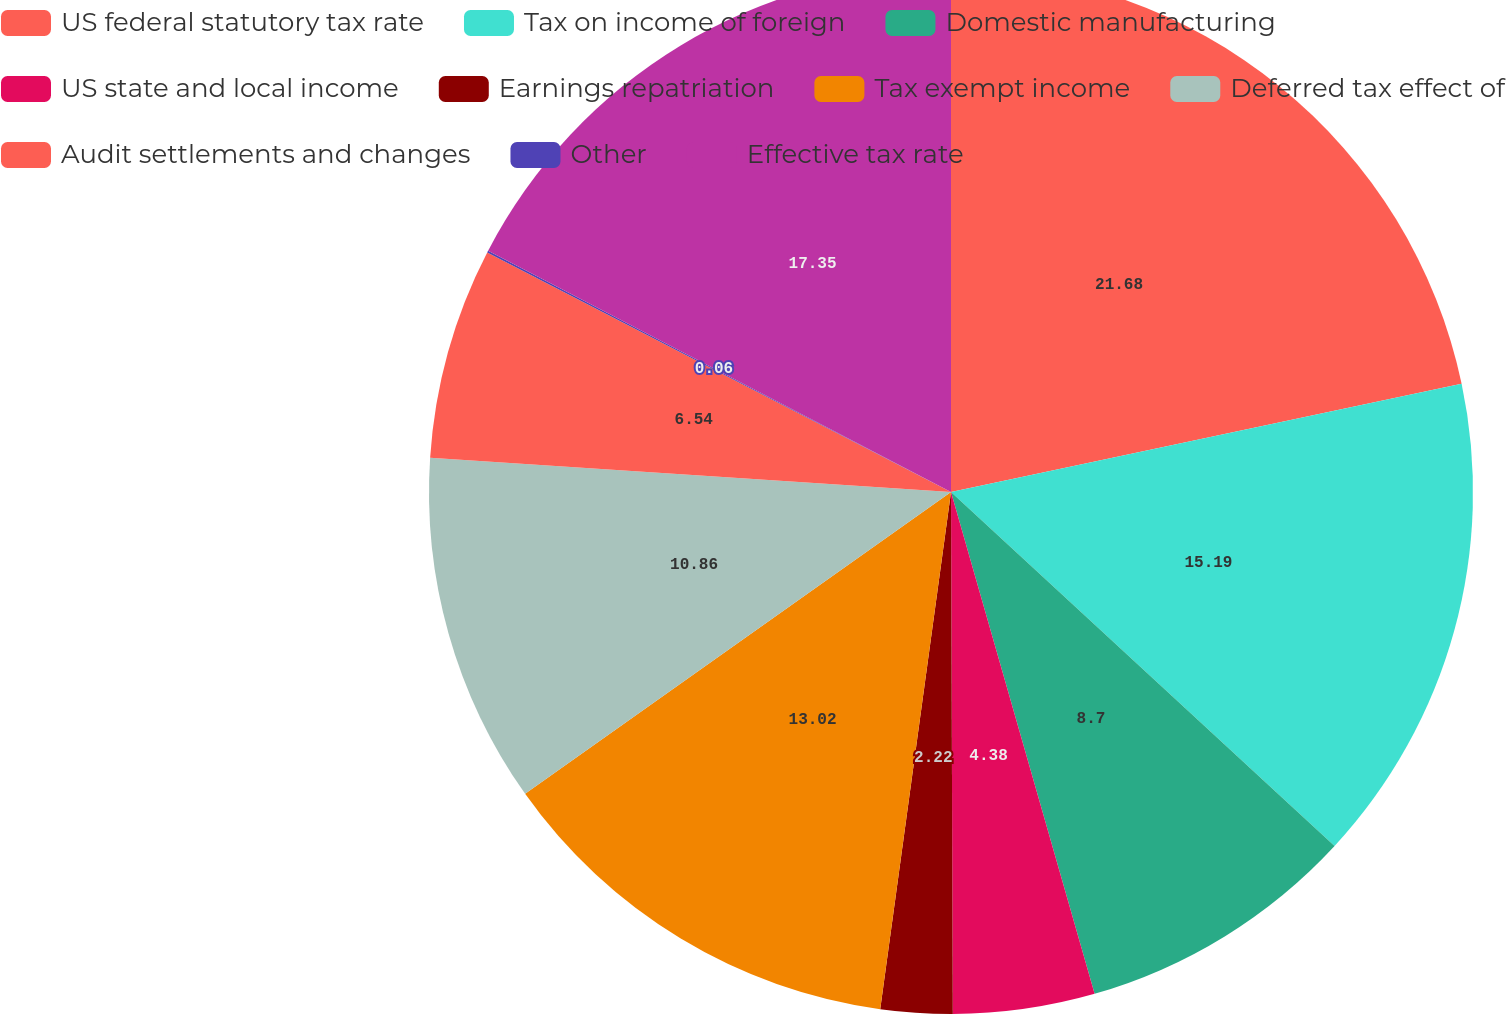Convert chart to OTSL. <chart><loc_0><loc_0><loc_500><loc_500><pie_chart><fcel>US federal statutory tax rate<fcel>Tax on income of foreign<fcel>Domestic manufacturing<fcel>US state and local income<fcel>Earnings repatriation<fcel>Tax exempt income<fcel>Deferred tax effect of<fcel>Audit settlements and changes<fcel>Other<fcel>Effective tax rate<nl><fcel>21.67%<fcel>15.19%<fcel>8.7%<fcel>4.38%<fcel>2.22%<fcel>13.02%<fcel>10.86%<fcel>6.54%<fcel>0.06%<fcel>17.35%<nl></chart> 